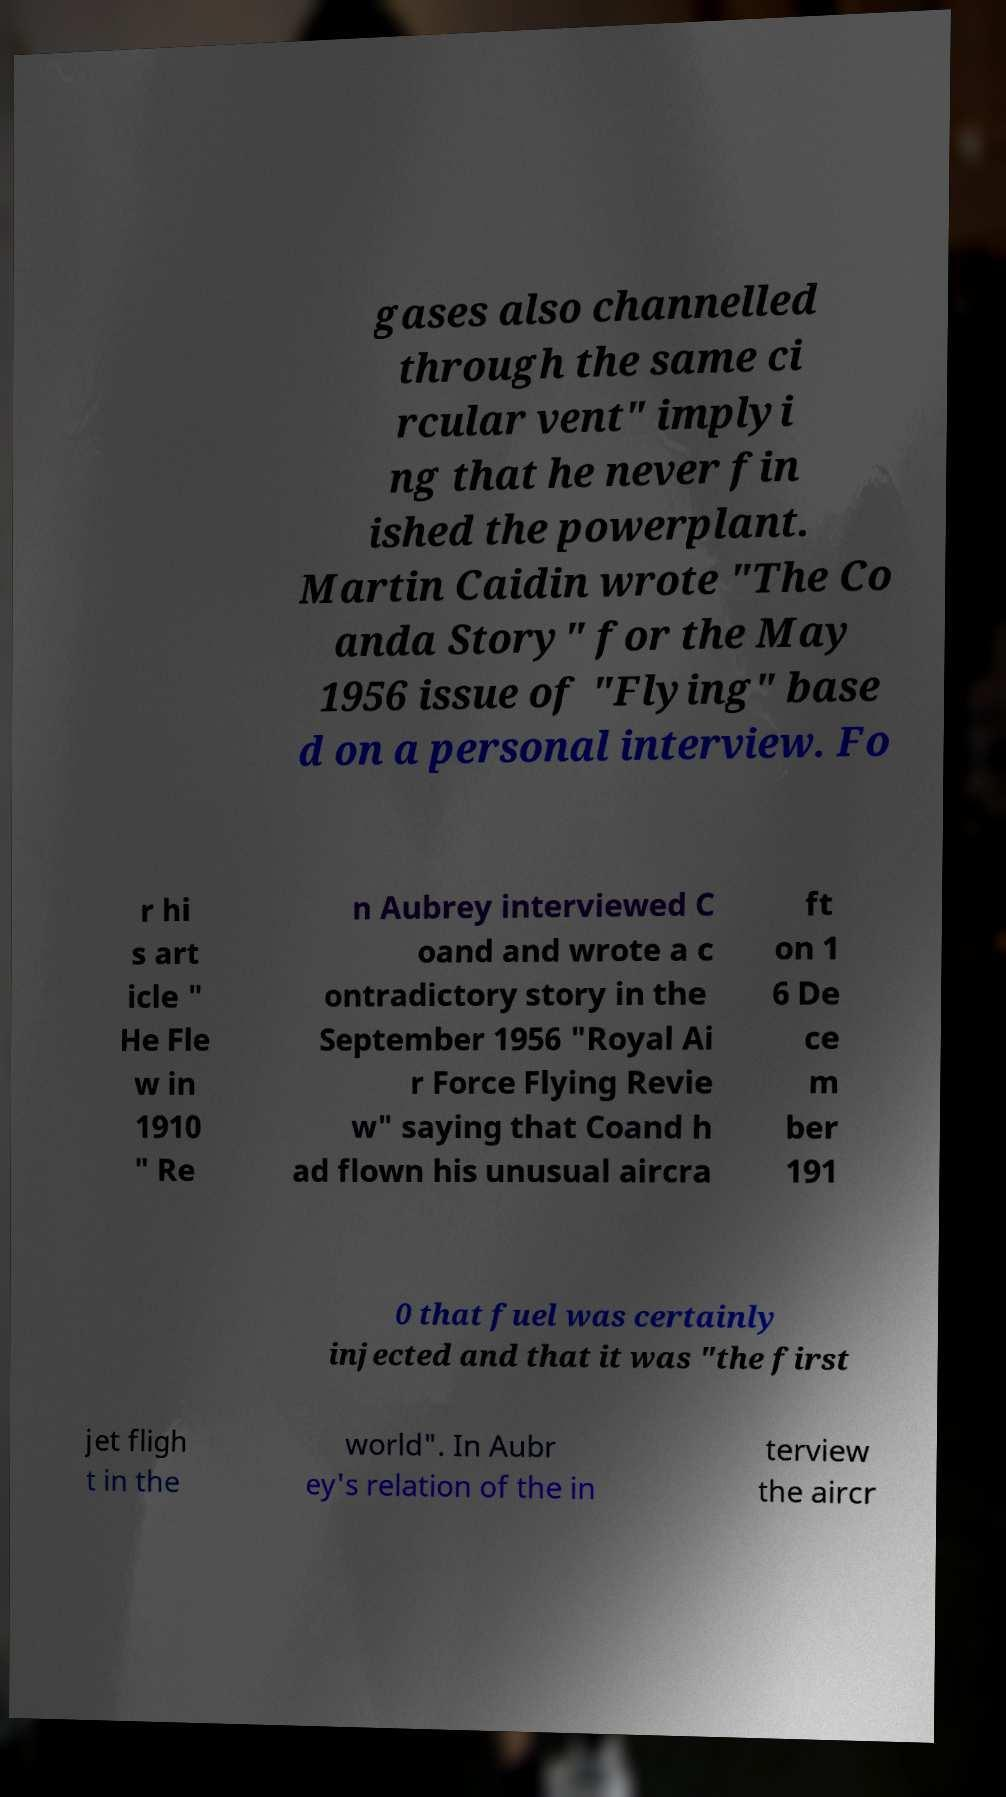Please read and relay the text visible in this image. What does it say? gases also channelled through the same ci rcular vent" implyi ng that he never fin ished the powerplant. Martin Caidin wrote "The Co anda Story" for the May 1956 issue of "Flying" base d on a personal interview. Fo r hi s art icle " He Fle w in 1910 " Re n Aubrey interviewed C oand and wrote a c ontradictory story in the September 1956 "Royal Ai r Force Flying Revie w" saying that Coand h ad flown his unusual aircra ft on 1 6 De ce m ber 191 0 that fuel was certainly injected and that it was "the first jet fligh t in the world". In Aubr ey's relation of the in terview the aircr 